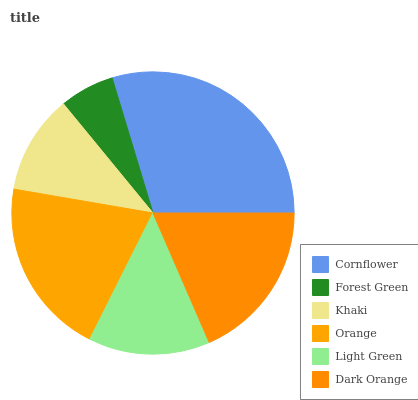Is Forest Green the minimum?
Answer yes or no. Yes. Is Cornflower the maximum?
Answer yes or no. Yes. Is Khaki the minimum?
Answer yes or no. No. Is Khaki the maximum?
Answer yes or no. No. Is Khaki greater than Forest Green?
Answer yes or no. Yes. Is Forest Green less than Khaki?
Answer yes or no. Yes. Is Forest Green greater than Khaki?
Answer yes or no. No. Is Khaki less than Forest Green?
Answer yes or no. No. Is Dark Orange the high median?
Answer yes or no. Yes. Is Light Green the low median?
Answer yes or no. Yes. Is Orange the high median?
Answer yes or no. No. Is Cornflower the low median?
Answer yes or no. No. 